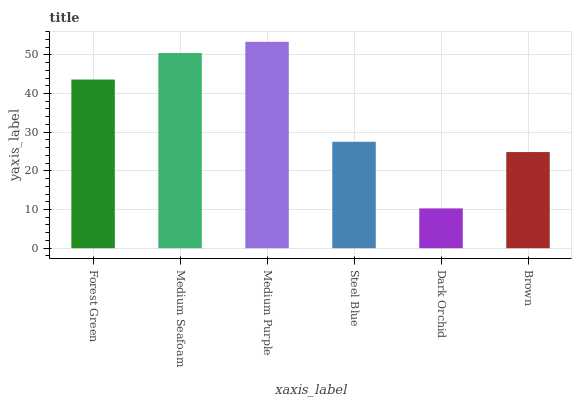Is Dark Orchid the minimum?
Answer yes or no. Yes. Is Medium Purple the maximum?
Answer yes or no. Yes. Is Medium Seafoam the minimum?
Answer yes or no. No. Is Medium Seafoam the maximum?
Answer yes or no. No. Is Medium Seafoam greater than Forest Green?
Answer yes or no. Yes. Is Forest Green less than Medium Seafoam?
Answer yes or no. Yes. Is Forest Green greater than Medium Seafoam?
Answer yes or no. No. Is Medium Seafoam less than Forest Green?
Answer yes or no. No. Is Forest Green the high median?
Answer yes or no. Yes. Is Steel Blue the low median?
Answer yes or no. Yes. Is Dark Orchid the high median?
Answer yes or no. No. Is Medium Seafoam the low median?
Answer yes or no. No. 